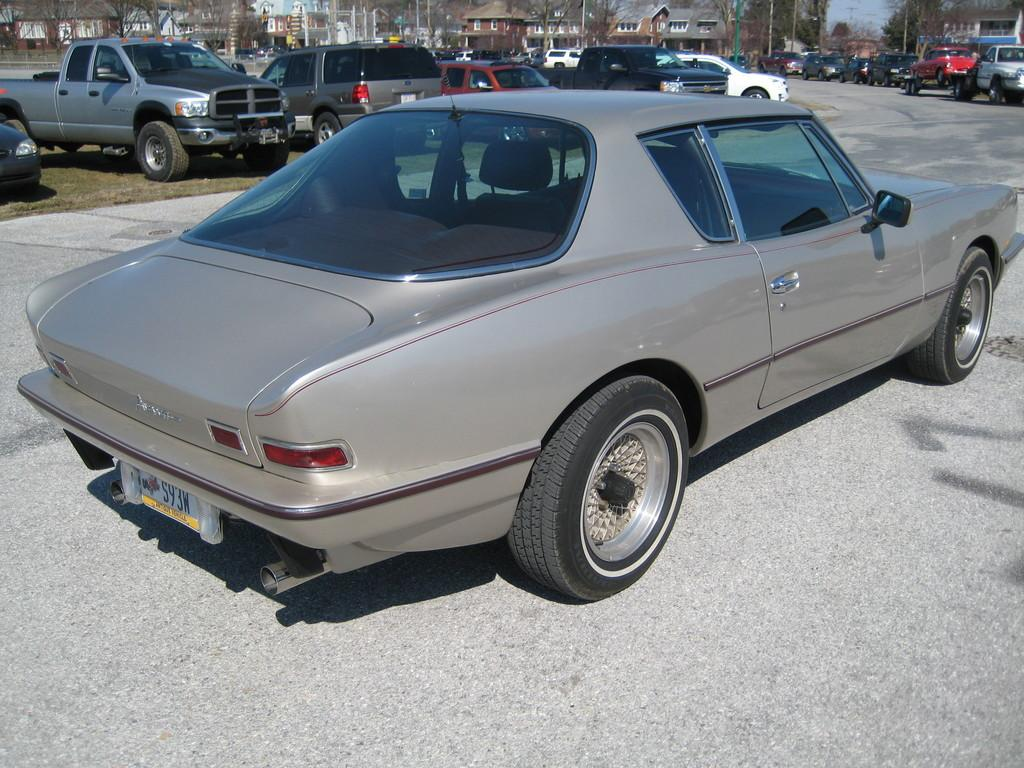What is the main feature of the image? There is a road in the image. What type of vehicle is on the road? There is a grey car on the road. What can be seen in the background of the image? There are multiple vehicles, trees, buildings, and the sky visible in the background. What type of tin can be seen in the image? There is no tin present in the image. How many houses are visible in the image? The image does not show any houses; it features a road, a grey car, and various elements in the background. 